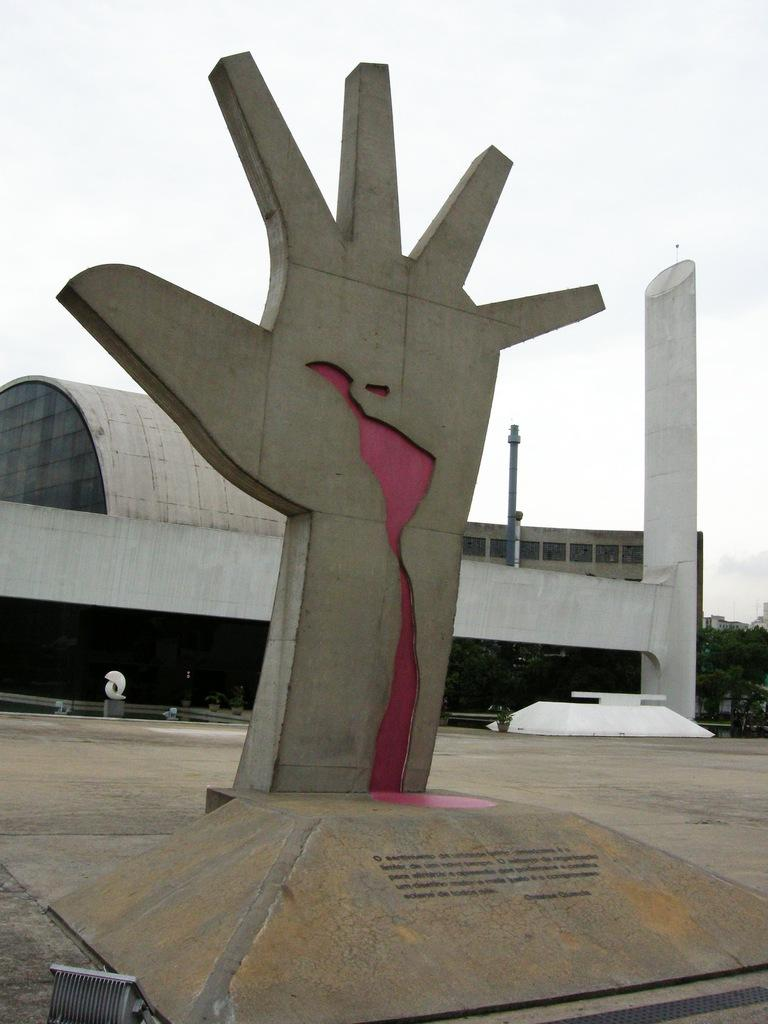What is the main subject of the image? The main subject of the image is a statue of a hand on a platform. What can be seen in the background of the image? There is a building, trees, a pole, and the sky visible in the background of the image. How many hens are sitting on the pole in the image? There are no hens present in the image; the pole is in the background without any hens. What type of game is being played on the platform with the statue? There is no game being played in the image; it features a statue of a hand on a platform. 